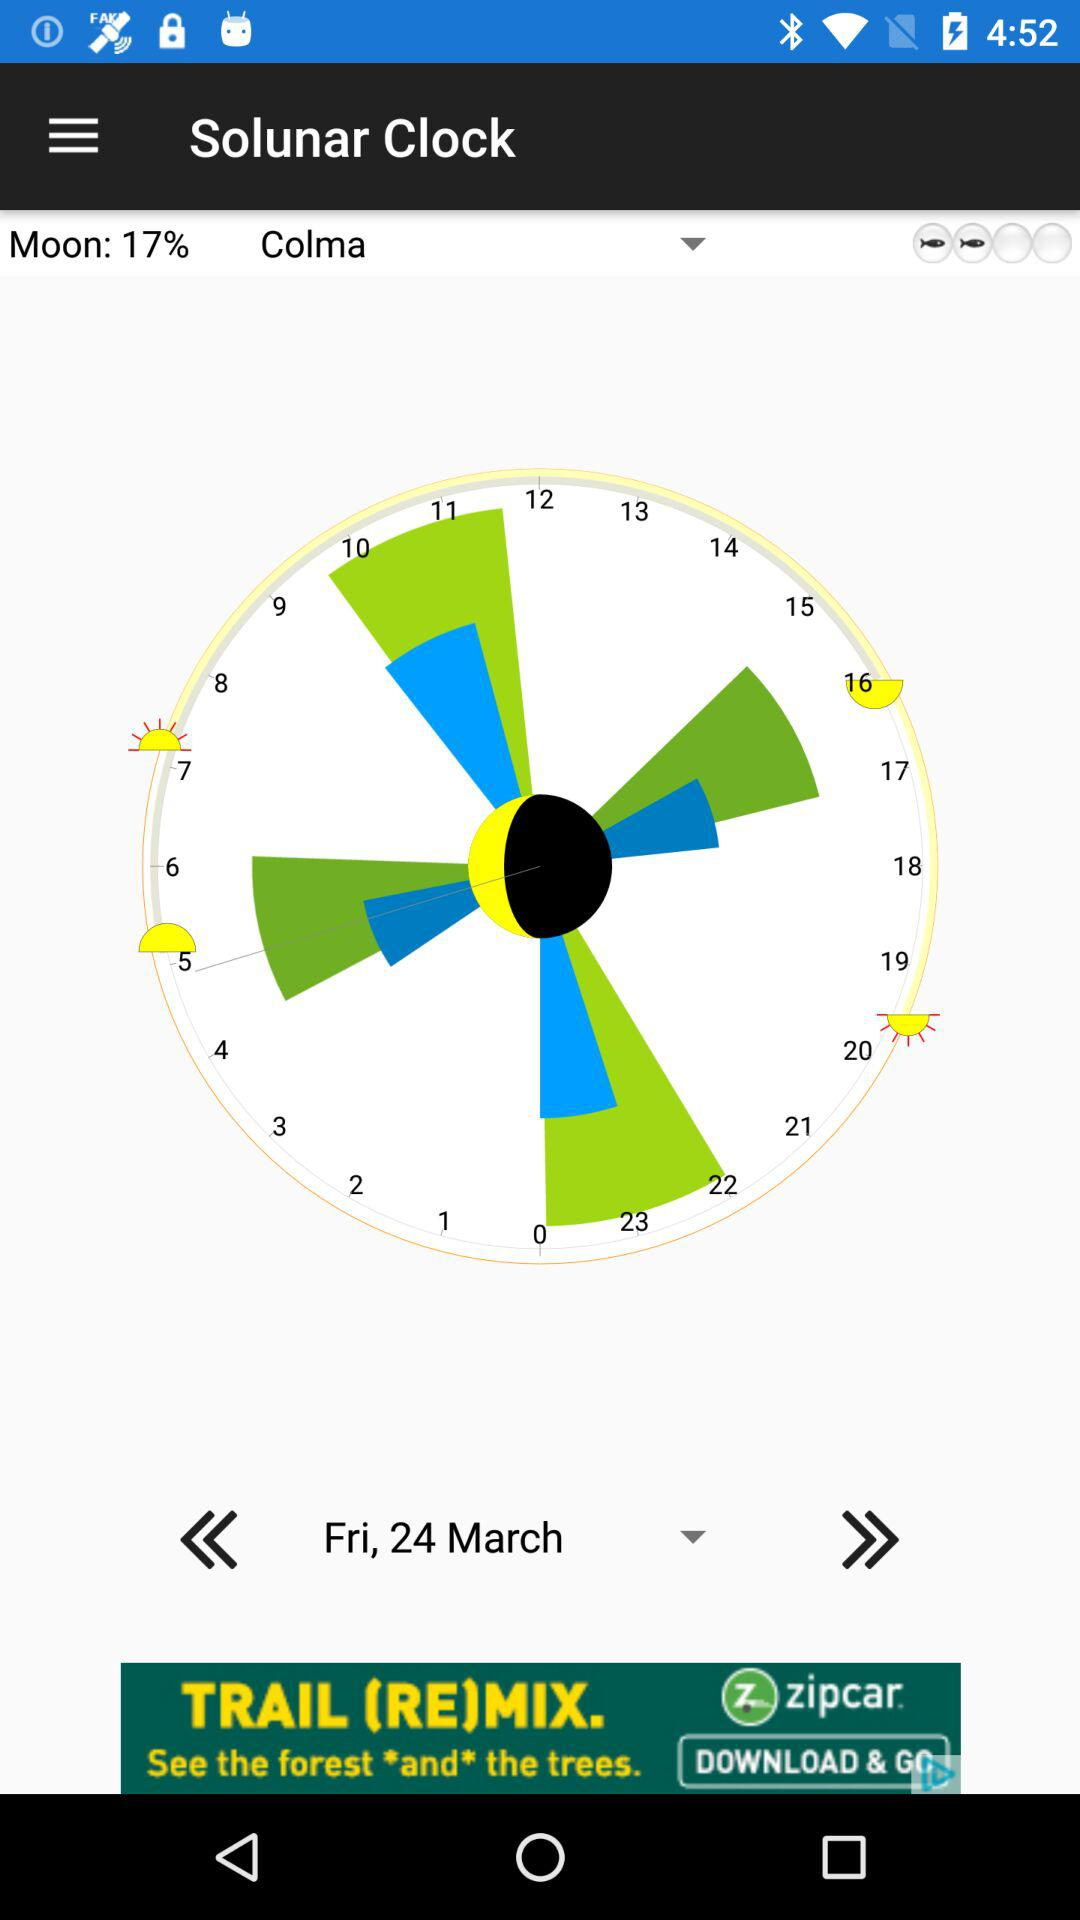What's the date? The date is Friday, March 24. 